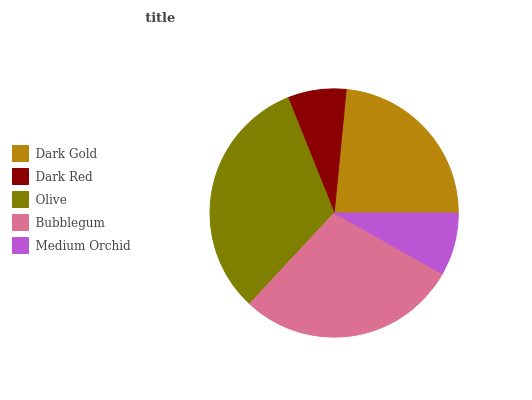Is Dark Red the minimum?
Answer yes or no. Yes. Is Olive the maximum?
Answer yes or no. Yes. Is Olive the minimum?
Answer yes or no. No. Is Dark Red the maximum?
Answer yes or no. No. Is Olive greater than Dark Red?
Answer yes or no. Yes. Is Dark Red less than Olive?
Answer yes or no. Yes. Is Dark Red greater than Olive?
Answer yes or no. No. Is Olive less than Dark Red?
Answer yes or no. No. Is Dark Gold the high median?
Answer yes or no. Yes. Is Dark Gold the low median?
Answer yes or no. Yes. Is Dark Red the high median?
Answer yes or no. No. Is Olive the low median?
Answer yes or no. No. 